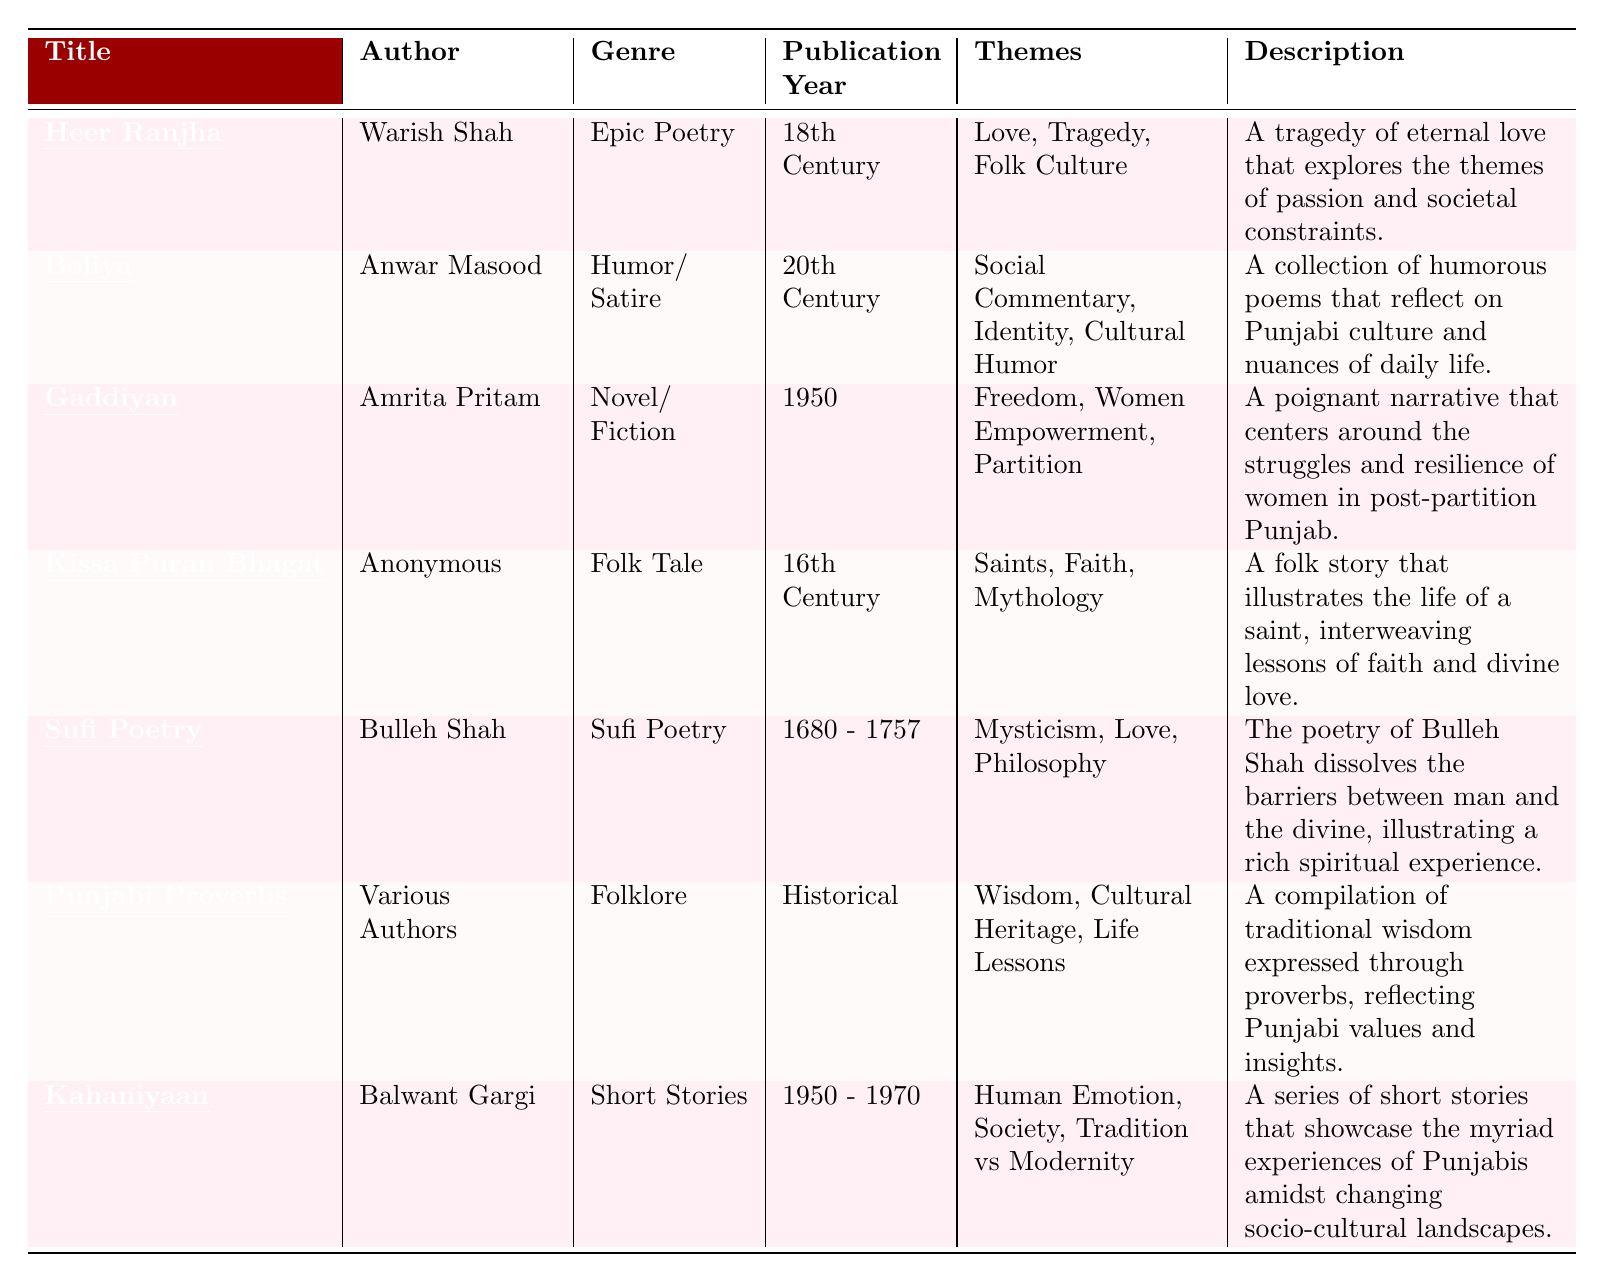What is the title of the text written by Warish Shah? The table lists the author Warish Shah and indicates that the title of his work is "Heer Ranjha."
Answer: Heer Ranjha Which genre does "Gaddiyan" belong to? According to the table, "Gaddiyan" is categorized under the genre of Novel/Fiction.
Answer: Novel/Fiction How many texts are authored by Anonymous? The table shows that "Kissa Puran Bhagat" is the only text written by an Anonymous author, so there is one text.
Answer: 1 Is "Sufi Poetry" written by Bulleh Shah? The table confirms that "Sufi Poetry" is indeed authored by Bulleh Shah.
Answer: Yes What year was "Boliya" published? The table indicates that "Boliya" was published in the 20th Century.
Answer: 20th Century What themes are explored in "Heer Ranjha"? The table lists the themes of "Heer Ranjha" as Love, Tragedy, and Folk Culture, which are derived from the data presented.
Answer: Love, Tragedy, Folk Culture Name the text that deals with women's empowerment. From the table, it is clear that "Gaddiyan" focuses on themes of Freedom and Women Empowerment.
Answer: Gaddiyan How many texts are from the 20th century? The table provides information on two texts published in the 20th century: "Boliya" and "Gaddiyan," totaling two texts from that period.
Answer: 2 Which text has the oldest publication year and its title? The table shows "Kissa Puran Bhagat," published in the 16th century, making it the oldest text.
Answer: Kissa Puran Bhagat Are the themes of "Punjabi Proverbs" related to cultural heritage? The table states that the themes of "Punjabi Proverbs" include Cultural Heritage, confirming a relation to cultural heritage.
Answer: Yes What is the total number of genres represented in the table? The table lists six distinct genres: Epic Poetry, Humor/Satire, Novel/Fiction, Folk Tale, Sufi Poetry, and Folklore, resulting in a total of six genres.
Answer: 6 Which author has works spanning multiple centuries? "Bulleh Shah" is noted in the table for "Sufi Poetry" to have lived between 1680 and 1757, indicating his work spans multiple centuries.
Answer: Bulleh Shah What is the primary theme of "Kahaniyaan"? The table identifies the themes of "Kahaniyaan" as Human Emotion, Society, and Tradition vs Modernity, making them its primary focus.
Answer: Human Emotion, Society, Tradition vs Modernity 